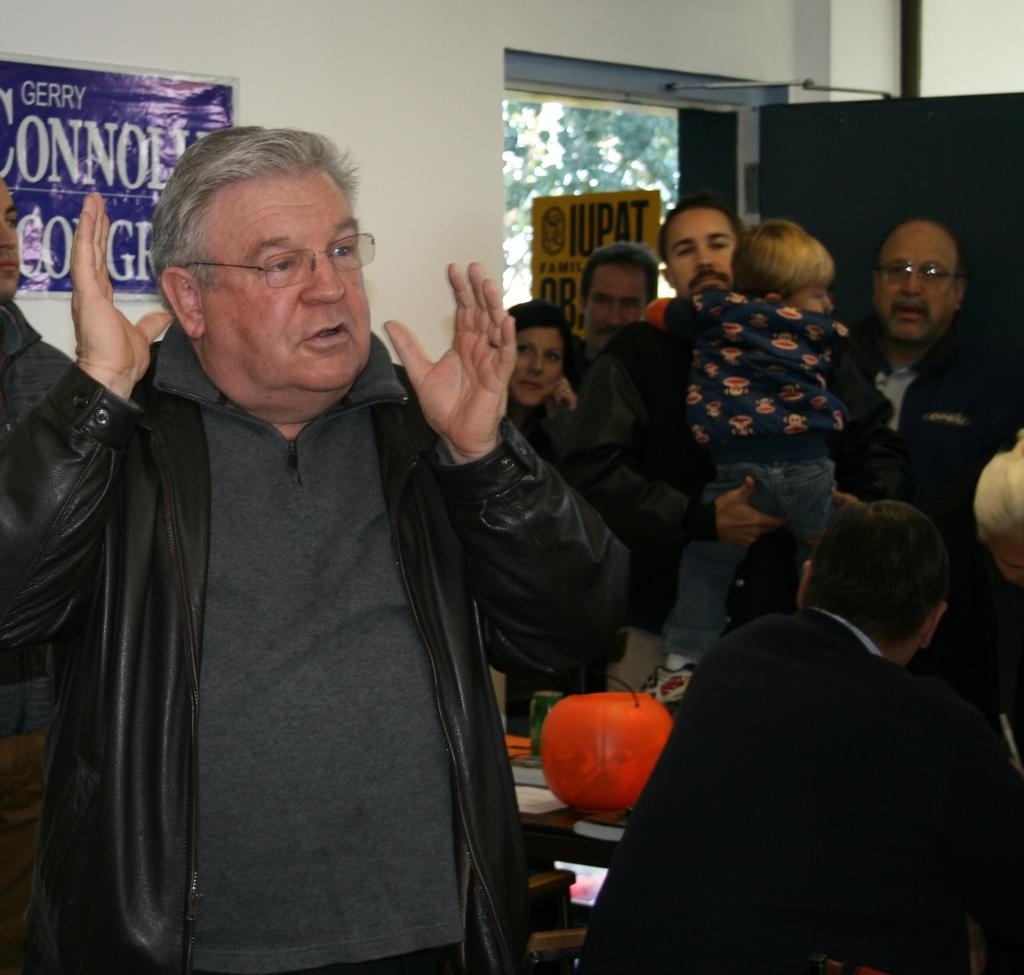What is the main subject of the image? The main subject of the image is an IUPAT union sign. What is the man in the image doing? The man is standing and speaking in the image. Where are the other people located in the image? The other people are standing beside a door in the image. What can be seen in the background of the image? There is a wall visible in the background of the image. What type of fairies can be seen flying around the IUPAT union sign in the image? There are no fairies present in the image; it only features the IUPAT union sign, a man speaking, and other people standing beside a door. What kind of apparel is the man wearing in the image? The provided facts do not mention the man's apparel, so we cannot determine what he is wearing from the image. 